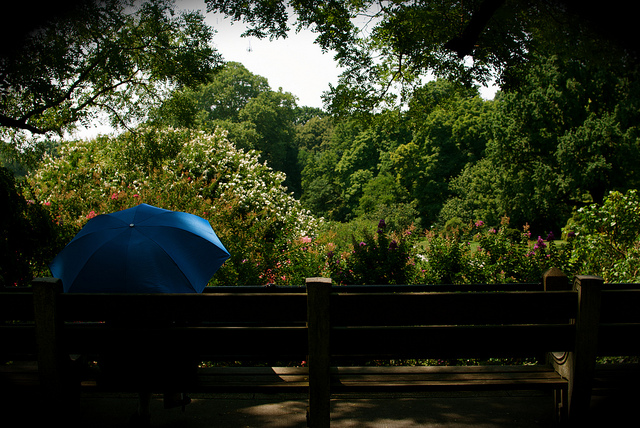<image>What are the people on the bench looking at? I don't know what the people on the bench are looking at. It could be trees, bushes, flowers or other aspects of nature. What are the people on the bench looking at? I don't know what the people on the bench are looking at. It can be trees, bushes, nature, flowers, or plants. 